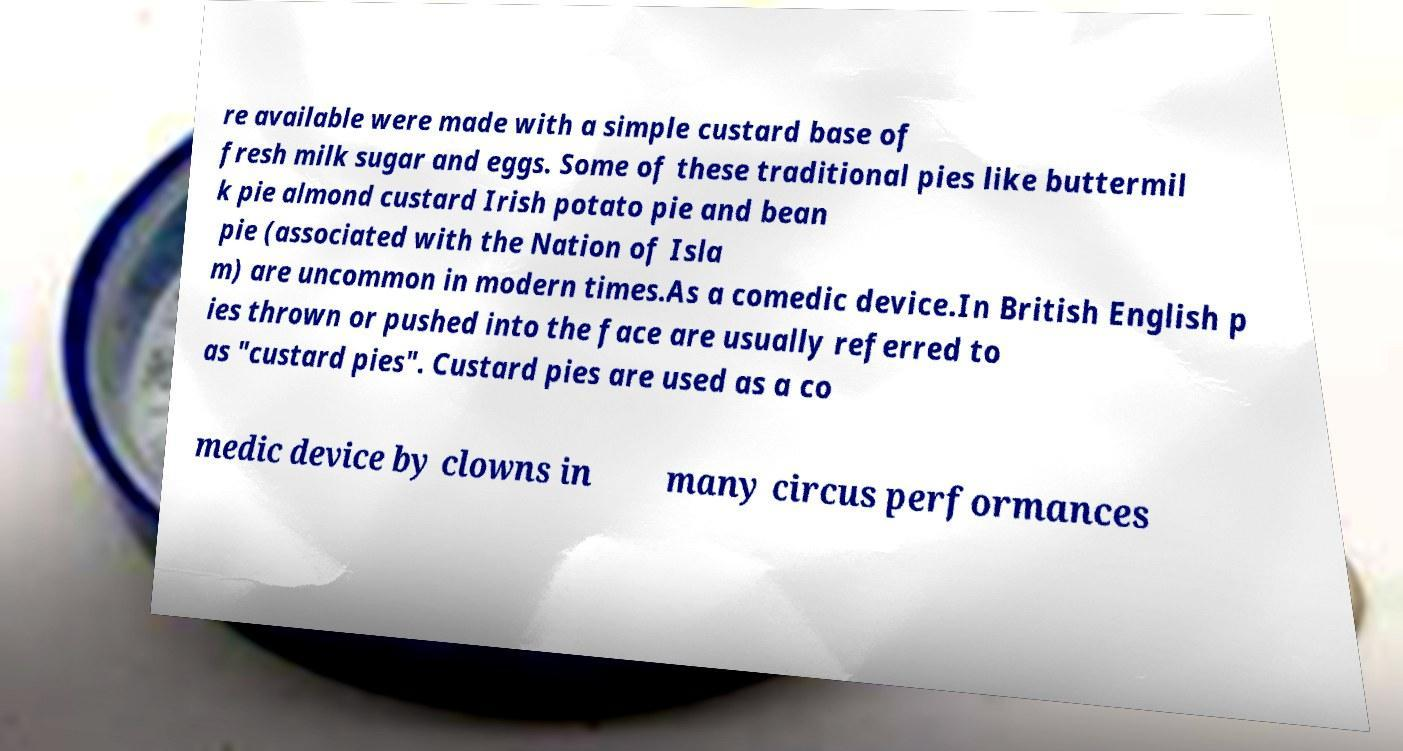Could you assist in decoding the text presented in this image and type it out clearly? re available were made with a simple custard base of fresh milk sugar and eggs. Some of these traditional pies like buttermil k pie almond custard Irish potato pie and bean pie (associated with the Nation of Isla m) are uncommon in modern times.As a comedic device.In British English p ies thrown or pushed into the face are usually referred to as "custard pies". Custard pies are used as a co medic device by clowns in many circus performances 